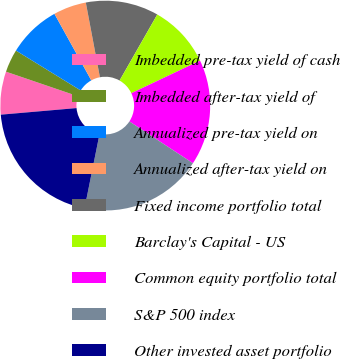Convert chart to OTSL. <chart><loc_0><loc_0><loc_500><loc_500><pie_chart><fcel>Imbedded pre-tax yield of cash<fcel>Imbedded after-tax yield of<fcel>Annualized pre-tax yield on<fcel>Annualized after-tax yield on<fcel>Fixed income portfolio total<fcel>Barclay's Capital - US<fcel>Common equity portfolio total<fcel>S&P 500 index<fcel>Other invested asset portfolio<nl><fcel>6.62%<fcel>3.55%<fcel>8.16%<fcel>5.08%<fcel>11.23%<fcel>9.69%<fcel>16.31%<fcel>18.91%<fcel>20.45%<nl></chart> 